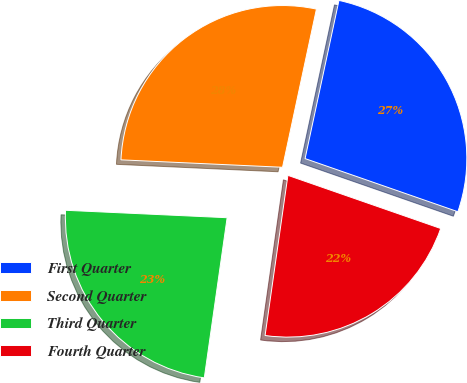Convert chart. <chart><loc_0><loc_0><loc_500><loc_500><pie_chart><fcel>First Quarter<fcel>Second Quarter<fcel>Third Quarter<fcel>Fourth Quarter<nl><fcel>26.97%<fcel>27.63%<fcel>23.48%<fcel>21.93%<nl></chart> 